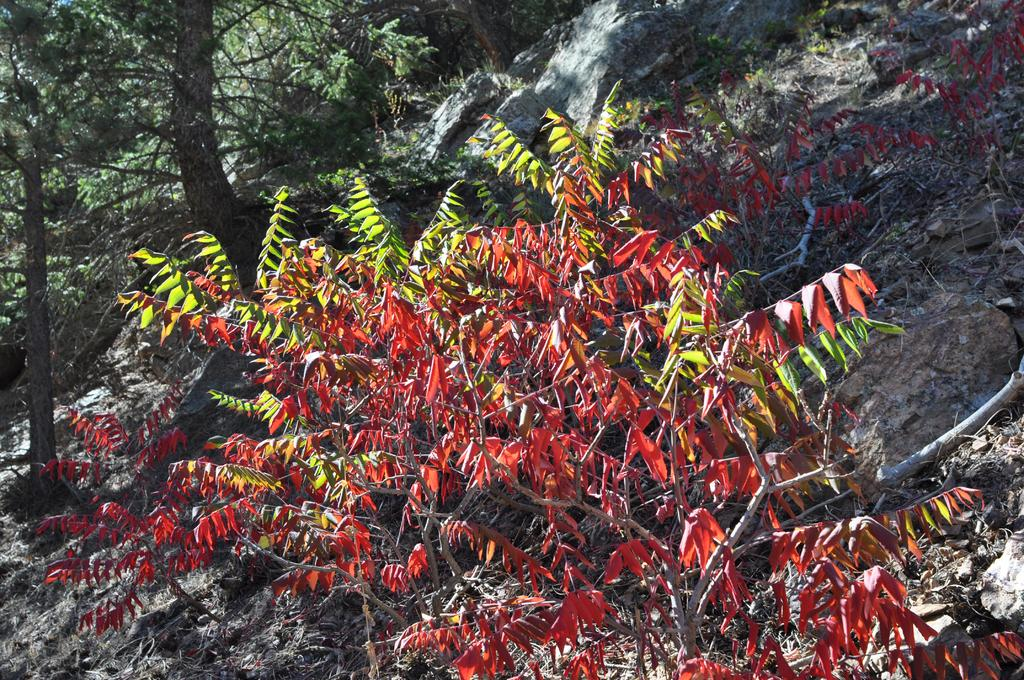What type of natural elements can be seen in the image? There are trees and rocks in the image. Can you describe the trees in the image? The provided facts do not give specific details about the trees, but they are present in the image. What other objects or features can be seen in the image? The provided facts only mention trees and rocks, so there is no additional information about other objects or features. How many feet are visible in the image? There are no feet present in the image; it features trees and rocks. What type of curve can be seen in the image? There is no curve present in the image; it features trees and rocks. 